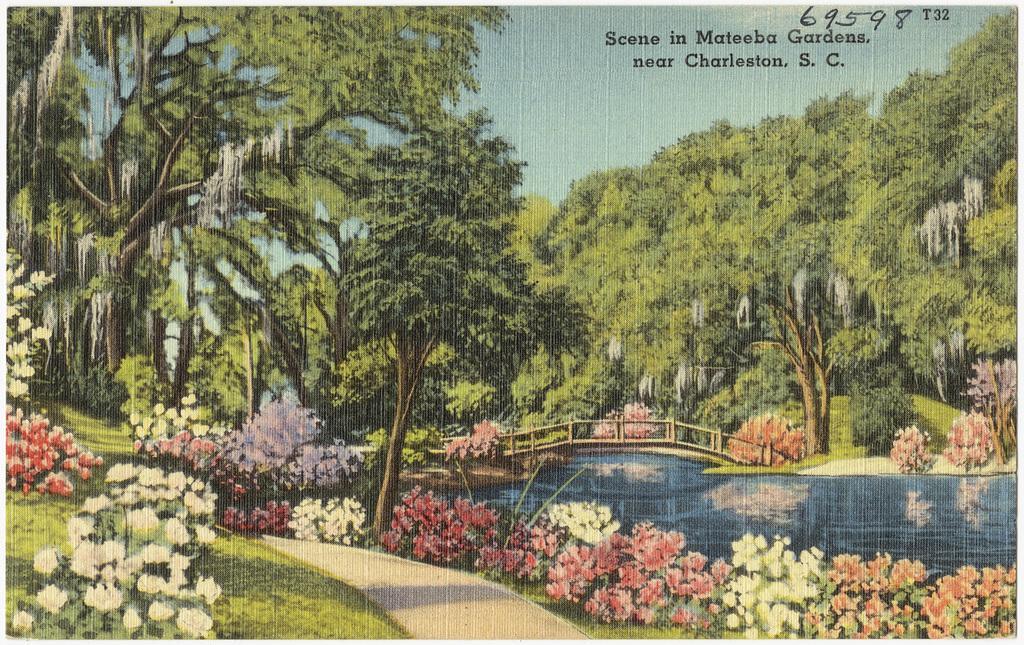Please provide a concise description of this image. In this image, we can see a poster with some trees, plants with flowers. We can also see some grass, water and the reflection of the plants in the water. We can also see a bridge. We can also see the sky. 